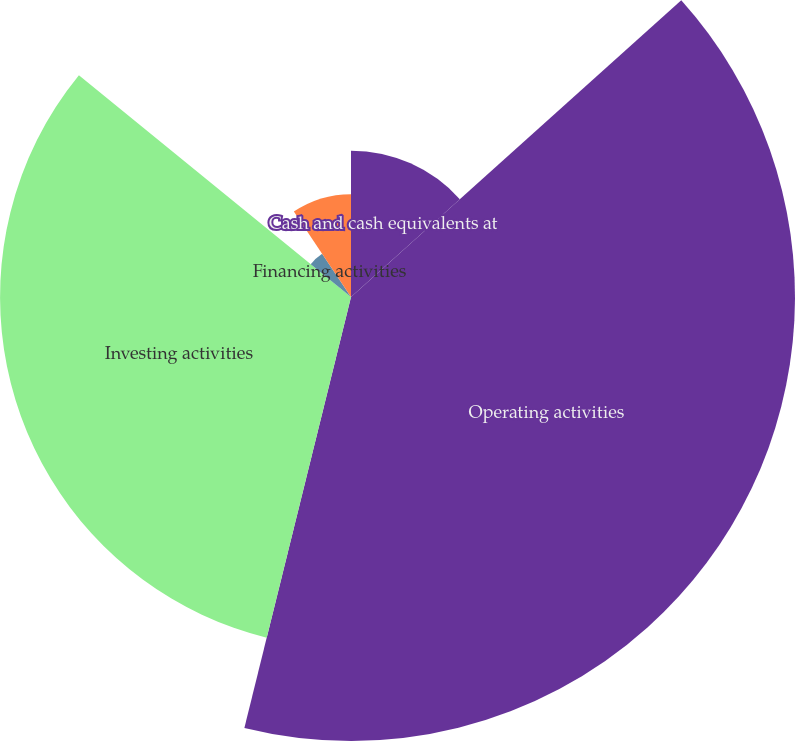<chart> <loc_0><loc_0><loc_500><loc_500><pie_chart><fcel>Cash and cash equivalents at<fcel>Operating activities<fcel>Investing activities<fcel>Financing activities<fcel>Net increase (decrease) in<nl><fcel>13.35%<fcel>40.51%<fcel>32.02%<fcel>4.74%<fcel>9.38%<nl></chart> 